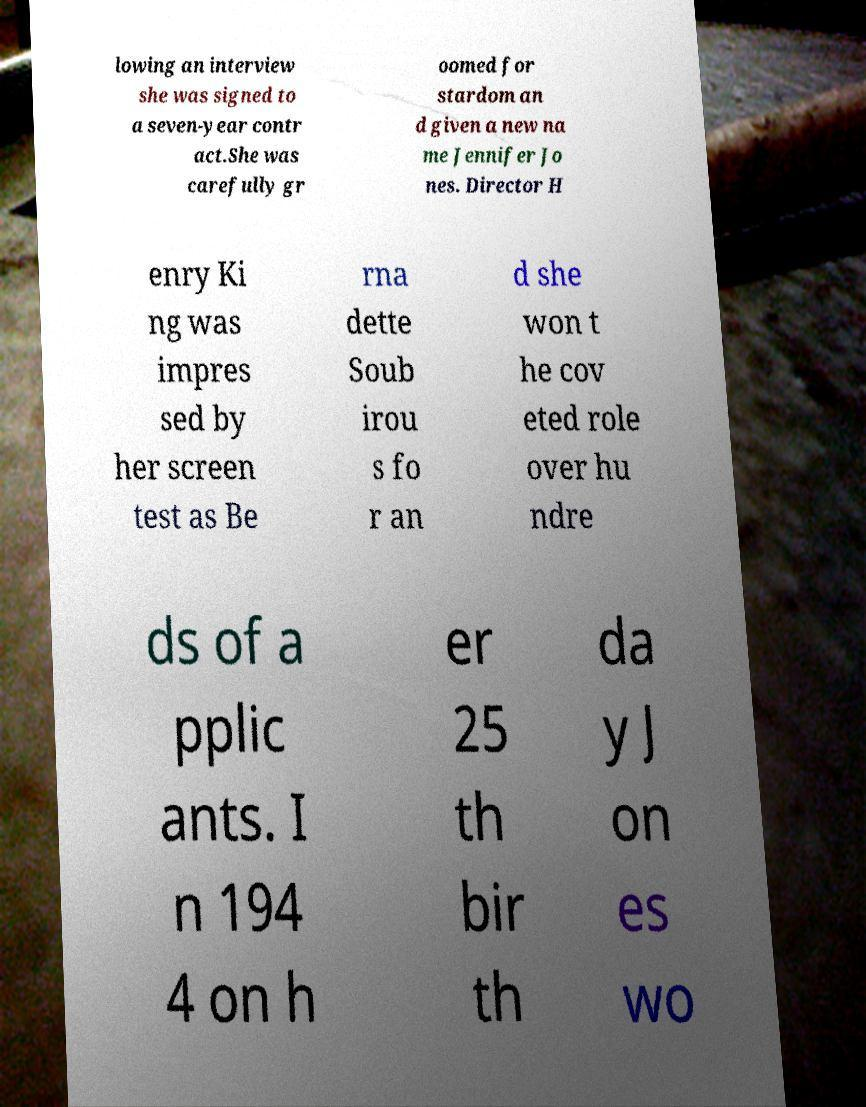There's text embedded in this image that I need extracted. Can you transcribe it verbatim? lowing an interview she was signed to a seven-year contr act.She was carefully gr oomed for stardom an d given a new na me Jennifer Jo nes. Director H enry Ki ng was impres sed by her screen test as Be rna dette Soub irou s fo r an d she won t he cov eted role over hu ndre ds of a pplic ants. I n 194 4 on h er 25 th bir th da y J on es wo 